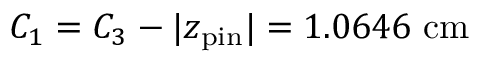<formula> <loc_0><loc_0><loc_500><loc_500>C _ { 1 } = C _ { 3 } - | z _ { p i n } | = 1 . 0 6 4 6 \ c m</formula> 